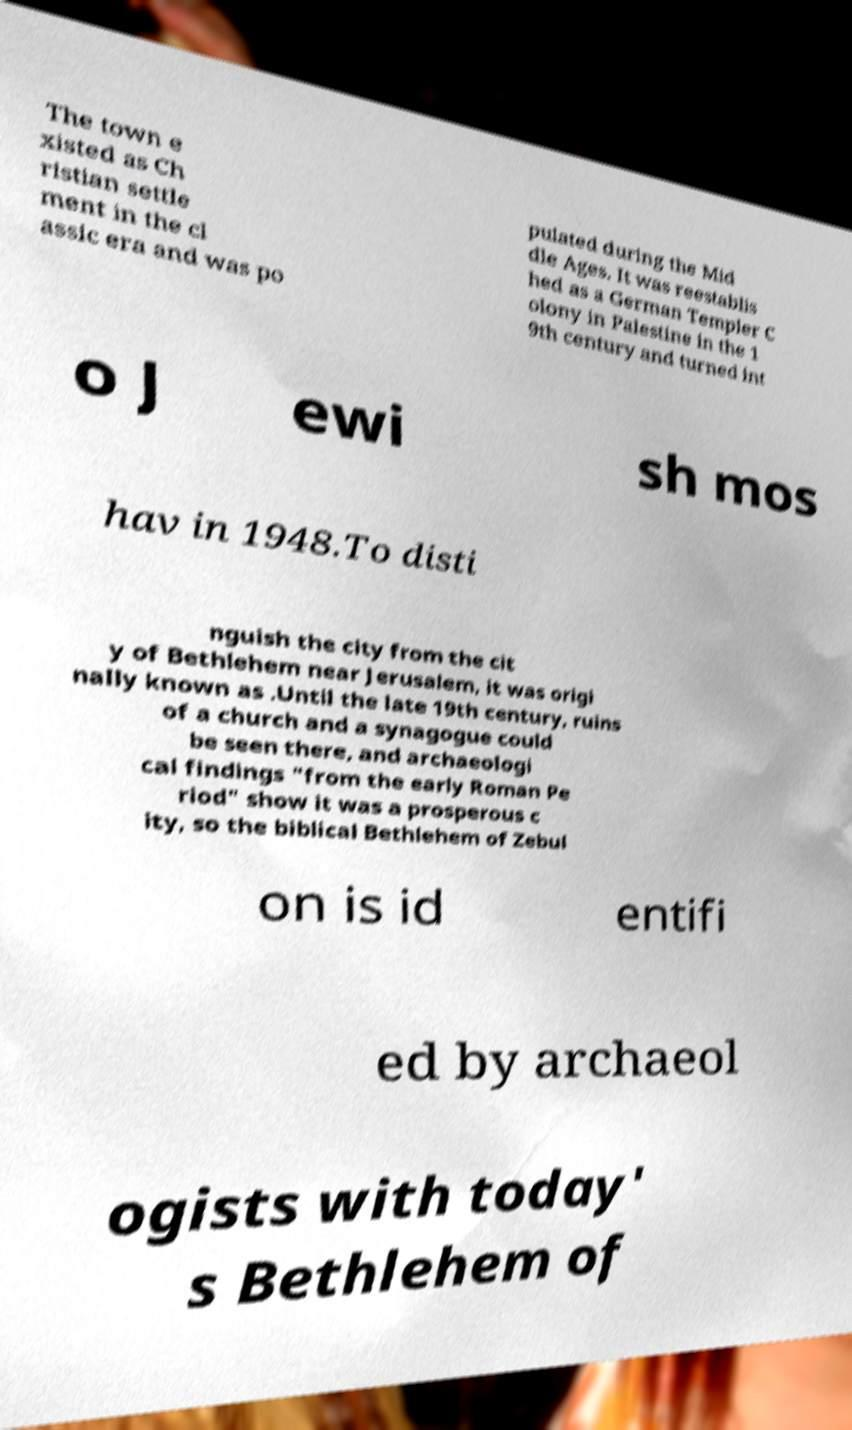Can you accurately transcribe the text from the provided image for me? The town e xisted as Ch ristian settle ment in the cl assic era and was po pulated during the Mid dle Ages. It was reestablis hed as a German Templer C olony in Palestine in the 1 9th century and turned int o J ewi sh mos hav in 1948.To disti nguish the city from the cit y of Bethlehem near Jerusalem, it was origi nally known as .Until the late 19th century, ruins of a church and a synagogue could be seen there, and archaeologi cal findings "from the early Roman Pe riod" show it was a prosperous c ity, so the biblical Bethlehem of Zebul on is id entifi ed by archaeol ogists with today' s Bethlehem of 